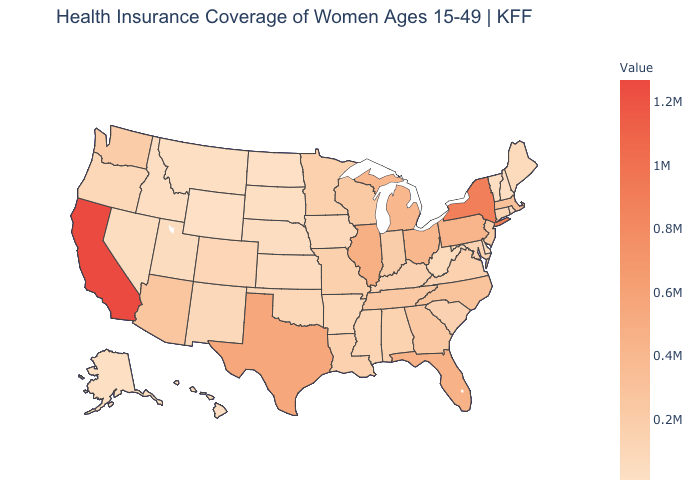Among the states that border Minnesota , does North Dakota have the lowest value?
Write a very short answer. Yes. Does Georgia have a lower value than Texas?
Short answer required. Yes. Does Texas have the highest value in the South?
Keep it brief. Yes. Does Oklahoma have the highest value in the USA?
Keep it brief. No. Which states have the highest value in the USA?
Concise answer only. California. Does New Jersey have a higher value than California?
Short answer required. No. 